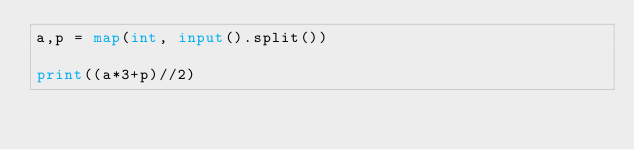Convert code to text. <code><loc_0><loc_0><loc_500><loc_500><_Python_>a,p = map(int, input().split())

print((a*3+p)//2)</code> 